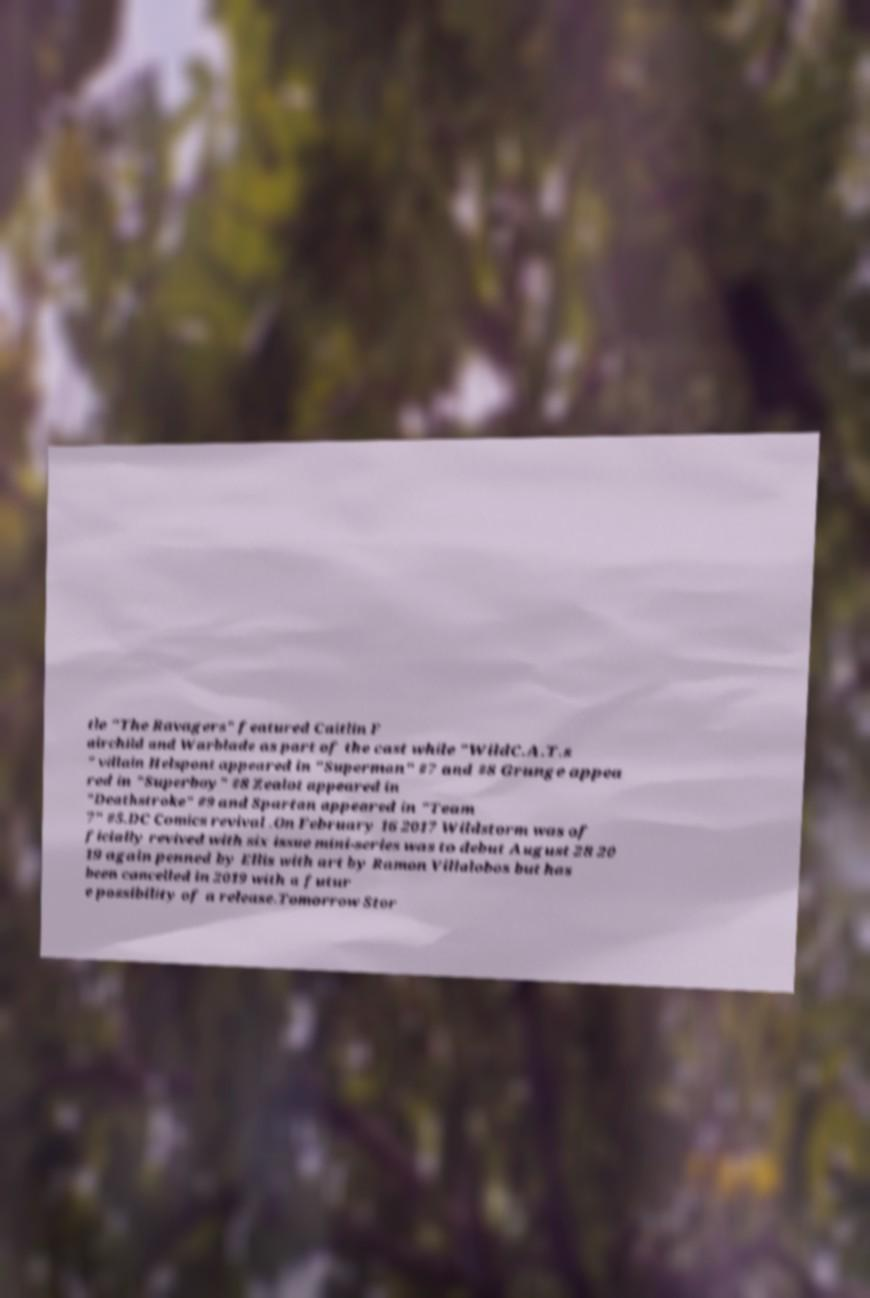There's text embedded in this image that I need extracted. Can you transcribe it verbatim? tle "The Ravagers" featured Caitlin F airchild and Warblade as part of the cast while "WildC.A.T.s " villain Helspont appeared in "Superman" #7 and #8 Grunge appea red in "Superboy" #8 Zealot appeared in "Deathstroke" #9 and Spartan appeared in "Team 7" #5.DC Comics revival .On February 16 2017 Wildstorm was of ficially revived with six issue mini-series was to debut August 28 20 19 again penned by Ellis with art by Ramon Villalobos but has been cancelled in 2019 with a futur e possibility of a release.Tomorrow Stor 